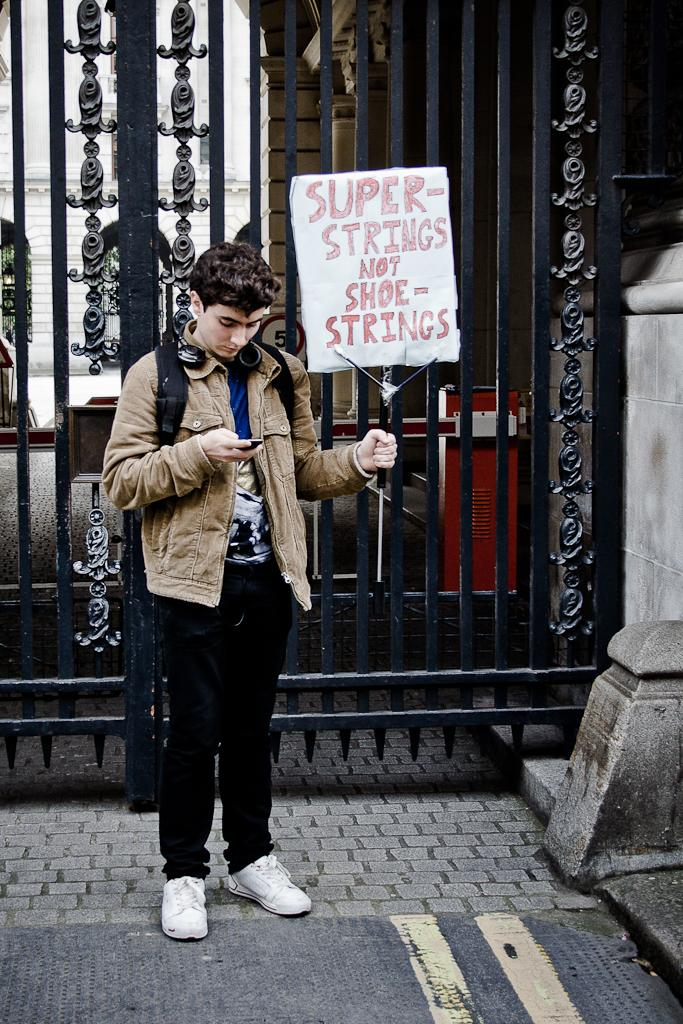Who is present in the image? There is a man in the image. What is the man doing in the image? The man is standing in front of a gate and holding a board. What is the man operating in the image? The man is operating a mobile. What type of powder can be seen on the man's jeans in the image? There is no powder or jeans present in the image. 